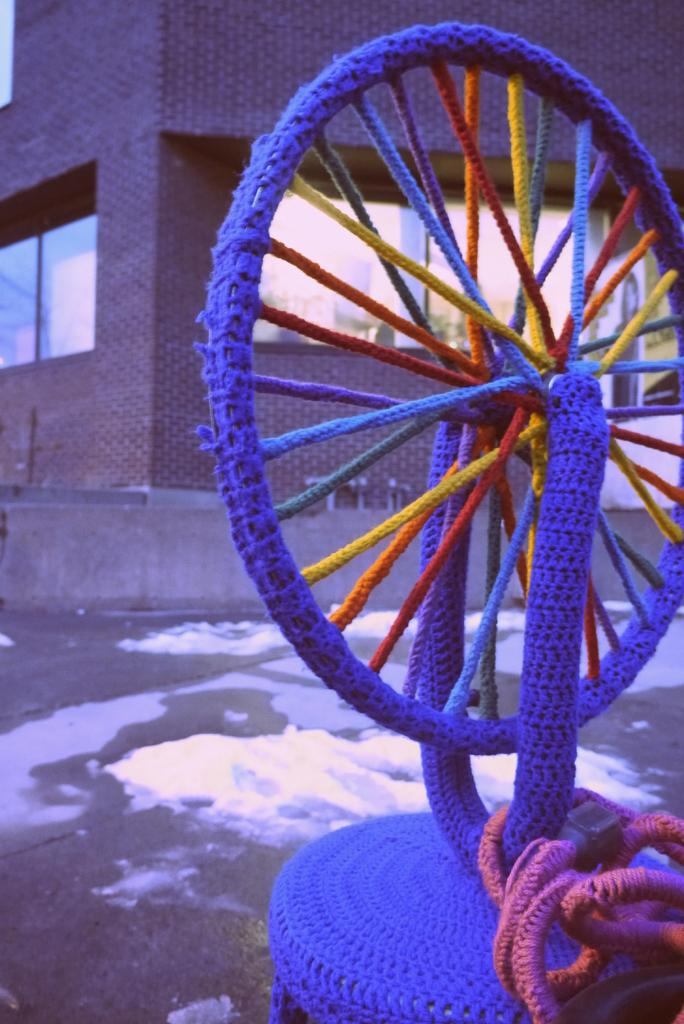What is the main subject of the image? The main subject of the image is a wheel covered with different colors of thread. Can you describe the wheel in more detail? The wheel has various colors of thread wrapped around it. What can be seen in the background of the image? There is a building in the background of the image. How many ghosts are visible in the image? There are no ghosts present in the image; it features a wheel covered with different colors of thread and a building in the background. What type of fish can be seen swimming near the wheel? There are no fish present in the image; it only features a wheel and a building in the background. 